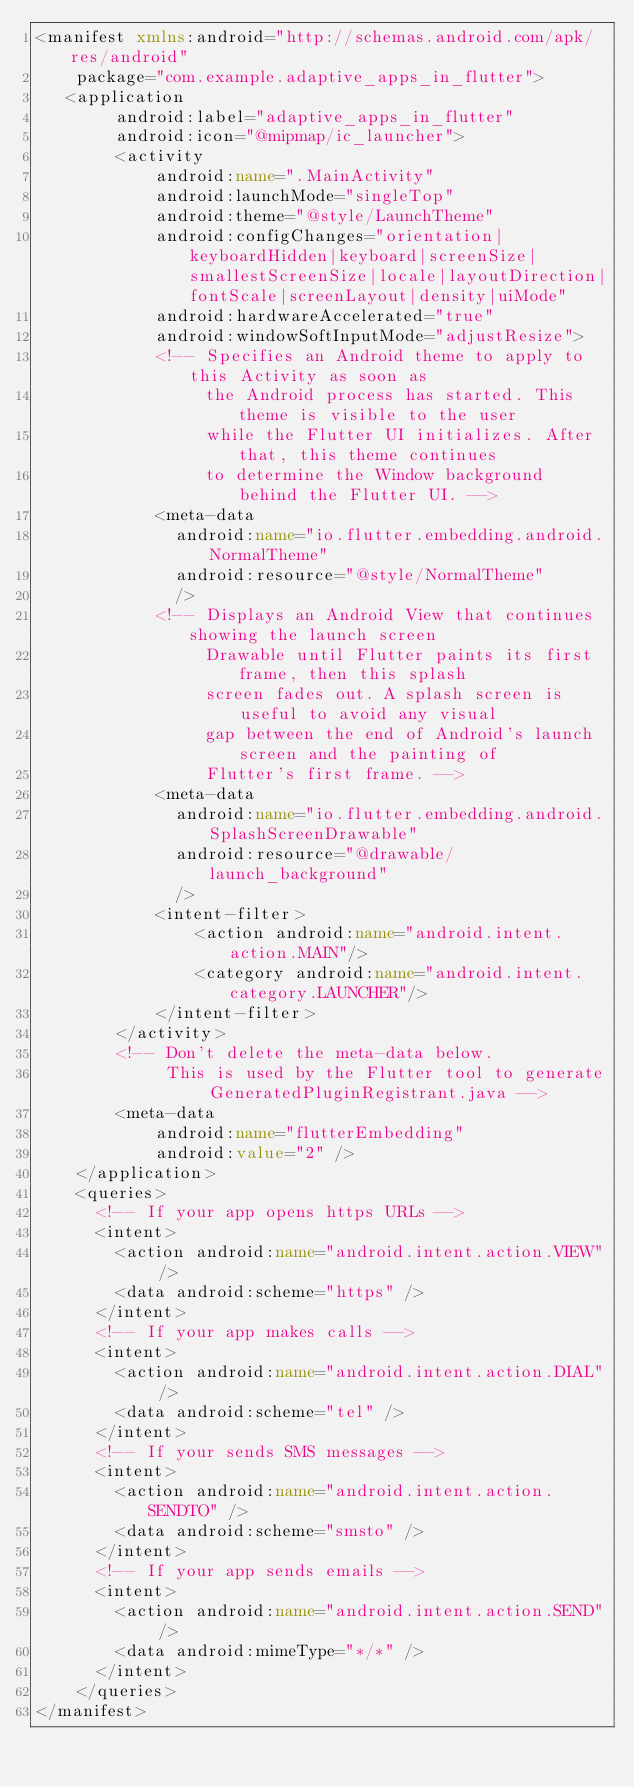<code> <loc_0><loc_0><loc_500><loc_500><_XML_><manifest xmlns:android="http://schemas.android.com/apk/res/android"
    package="com.example.adaptive_apps_in_flutter">
   <application
        android:label="adaptive_apps_in_flutter"
        android:icon="@mipmap/ic_launcher">
        <activity
            android:name=".MainActivity"
            android:launchMode="singleTop"
            android:theme="@style/LaunchTheme"
            android:configChanges="orientation|keyboardHidden|keyboard|screenSize|smallestScreenSize|locale|layoutDirection|fontScale|screenLayout|density|uiMode"
            android:hardwareAccelerated="true"
            android:windowSoftInputMode="adjustResize">
            <!-- Specifies an Android theme to apply to this Activity as soon as
                 the Android process has started. This theme is visible to the user
                 while the Flutter UI initializes. After that, this theme continues
                 to determine the Window background behind the Flutter UI. -->
            <meta-data
              android:name="io.flutter.embedding.android.NormalTheme"
              android:resource="@style/NormalTheme"
              />
            <!-- Displays an Android View that continues showing the launch screen
                 Drawable until Flutter paints its first frame, then this splash
                 screen fades out. A splash screen is useful to avoid any visual
                 gap between the end of Android's launch screen and the painting of
                 Flutter's first frame. -->
            <meta-data
              android:name="io.flutter.embedding.android.SplashScreenDrawable"
              android:resource="@drawable/launch_background"
              />
            <intent-filter>
                <action android:name="android.intent.action.MAIN"/>
                <category android:name="android.intent.category.LAUNCHER"/>
            </intent-filter>
        </activity>
        <!-- Don't delete the meta-data below.
             This is used by the Flutter tool to generate GeneratedPluginRegistrant.java -->
        <meta-data
            android:name="flutterEmbedding"
            android:value="2" />
    </application>
    <queries>
      <!-- If your app opens https URLs -->
      <intent>
        <action android:name="android.intent.action.VIEW" />
        <data android:scheme="https" />
      </intent>
      <!-- If your app makes calls -->
      <intent>
        <action android:name="android.intent.action.DIAL" />
        <data android:scheme="tel" />
      </intent>
      <!-- If your sends SMS messages -->
      <intent>
        <action android:name="android.intent.action.SENDTO" />
        <data android:scheme="smsto" />
      </intent>
      <!-- If your app sends emails -->
      <intent>
        <action android:name="android.intent.action.SEND" />
        <data android:mimeType="*/*" />
      </intent>
    </queries>
</manifest>
</code> 